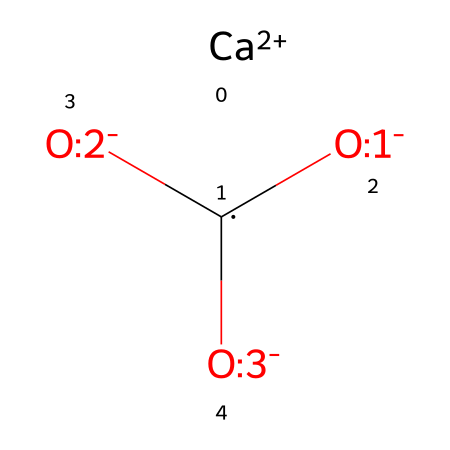What is the chemical name of this compound? The structure corresponds to calcium carbonate, which is comprised of calcium ions and carbonate ions. The presence of [Ca+2] indicates the calcium component and the connecting oxygen atoms from the carbonate ions suggest the carbonate configuration.
Answer: calcium carbonate How many oxygen atoms are present in this structure? By examining the SMILES representation, we can see three oxygen atoms indicated by [O-] that are part of the carbonate ion structure. This confirms that there are three oxygen atoms in total.
Answer: three What is the charge of the calcium ion in this structure? The calcium ion is denoted as [Ca+2] in the SMILES, indicating it has a positive charge of +2. This is characteristic of calcium when it forms ionic compounds.
Answer: +2 What type of bond connects calcium to carbonate? The bond between calcium and carbonate is ionic. Calcium typically forms ionic bonds by donating two electrons to achieve a stable electronic configuration, resulting in an attraction to the negatively charged carbonate ion.
Answer: ionic What is the total number of atoms in this chemical structure? The structure consists of one calcium atom, one carbon atom, and three oxygen atoms. Adding these gives a total of five atoms in the entire compound.
Answer: five Is this compound acidic, basic, or neutral? Calcium carbonate is generally considered to be neutral due to the balance of acidic (from carbonic acid) and basic (from calcium hydroxide) properties it exhibits in solution.
Answer: neutral 